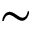<formula> <loc_0><loc_0><loc_500><loc_500>\sim</formula> 